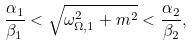Convert formula to latex. <formula><loc_0><loc_0><loc_500><loc_500>\frac { \alpha _ { 1 } } { \beta _ { 1 } } < \sqrt { \omega _ { \Omega , 1 } ^ { 2 } + m ^ { 2 } } < \frac { \alpha _ { 2 } } { \beta _ { 2 } } ,</formula> 